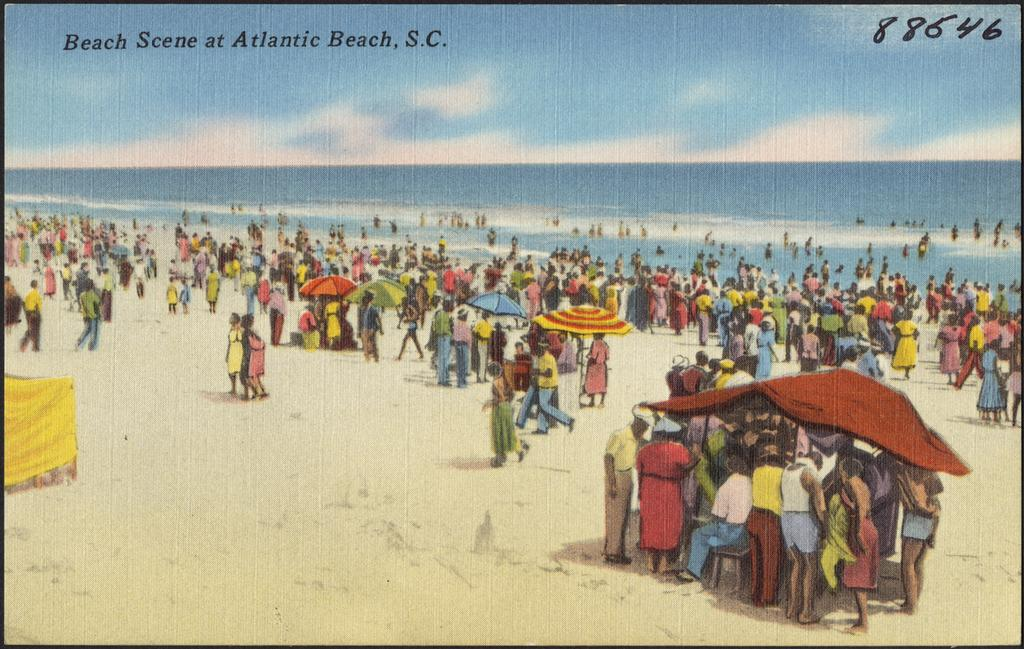<image>
Summarize the visual content of the image. A painting that says Beach Scene at Atlantic beach, S.C. with the number 88646 written in the upper right corner. 